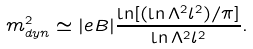Convert formula to latex. <formula><loc_0><loc_0><loc_500><loc_500>m _ { d y n } ^ { 2 } \simeq | e B | \frac { \ln [ ( \ln \Lambda ^ { 2 } l ^ { 2 } ) / \pi ] } { \ln \Lambda ^ { 2 } l ^ { 2 } } .</formula> 